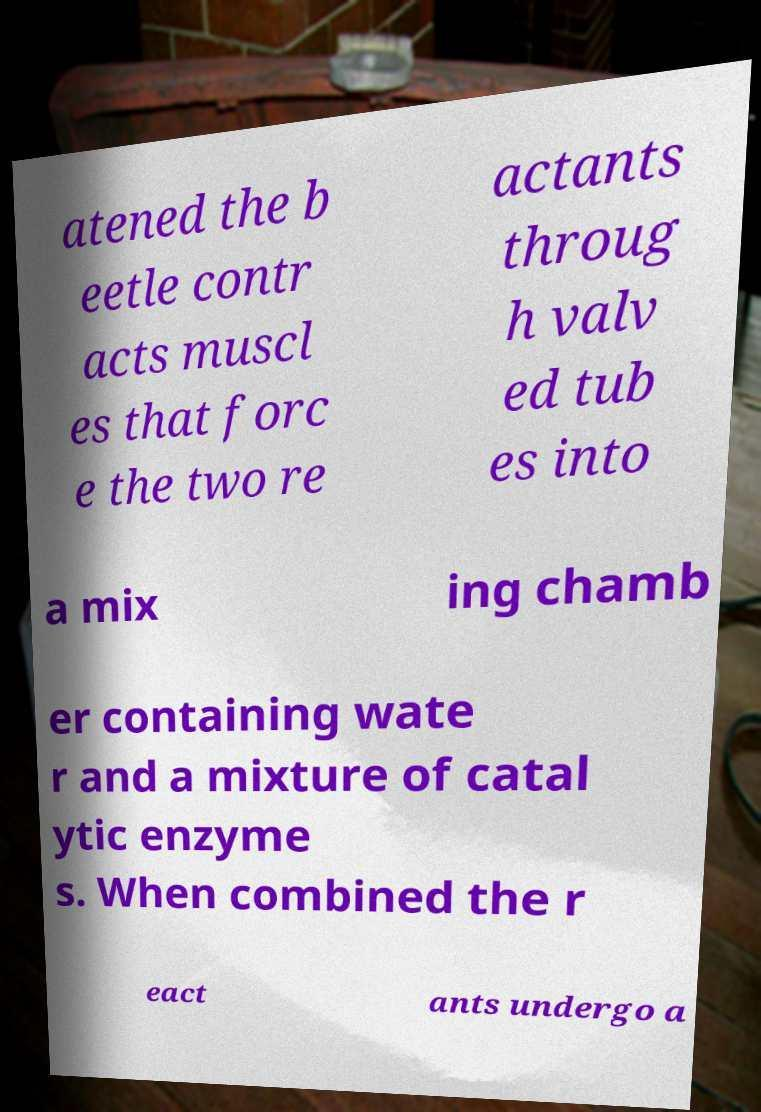Please identify and transcribe the text found in this image. atened the b eetle contr acts muscl es that forc e the two re actants throug h valv ed tub es into a mix ing chamb er containing wate r and a mixture of catal ytic enzyme s. When combined the r eact ants undergo a 